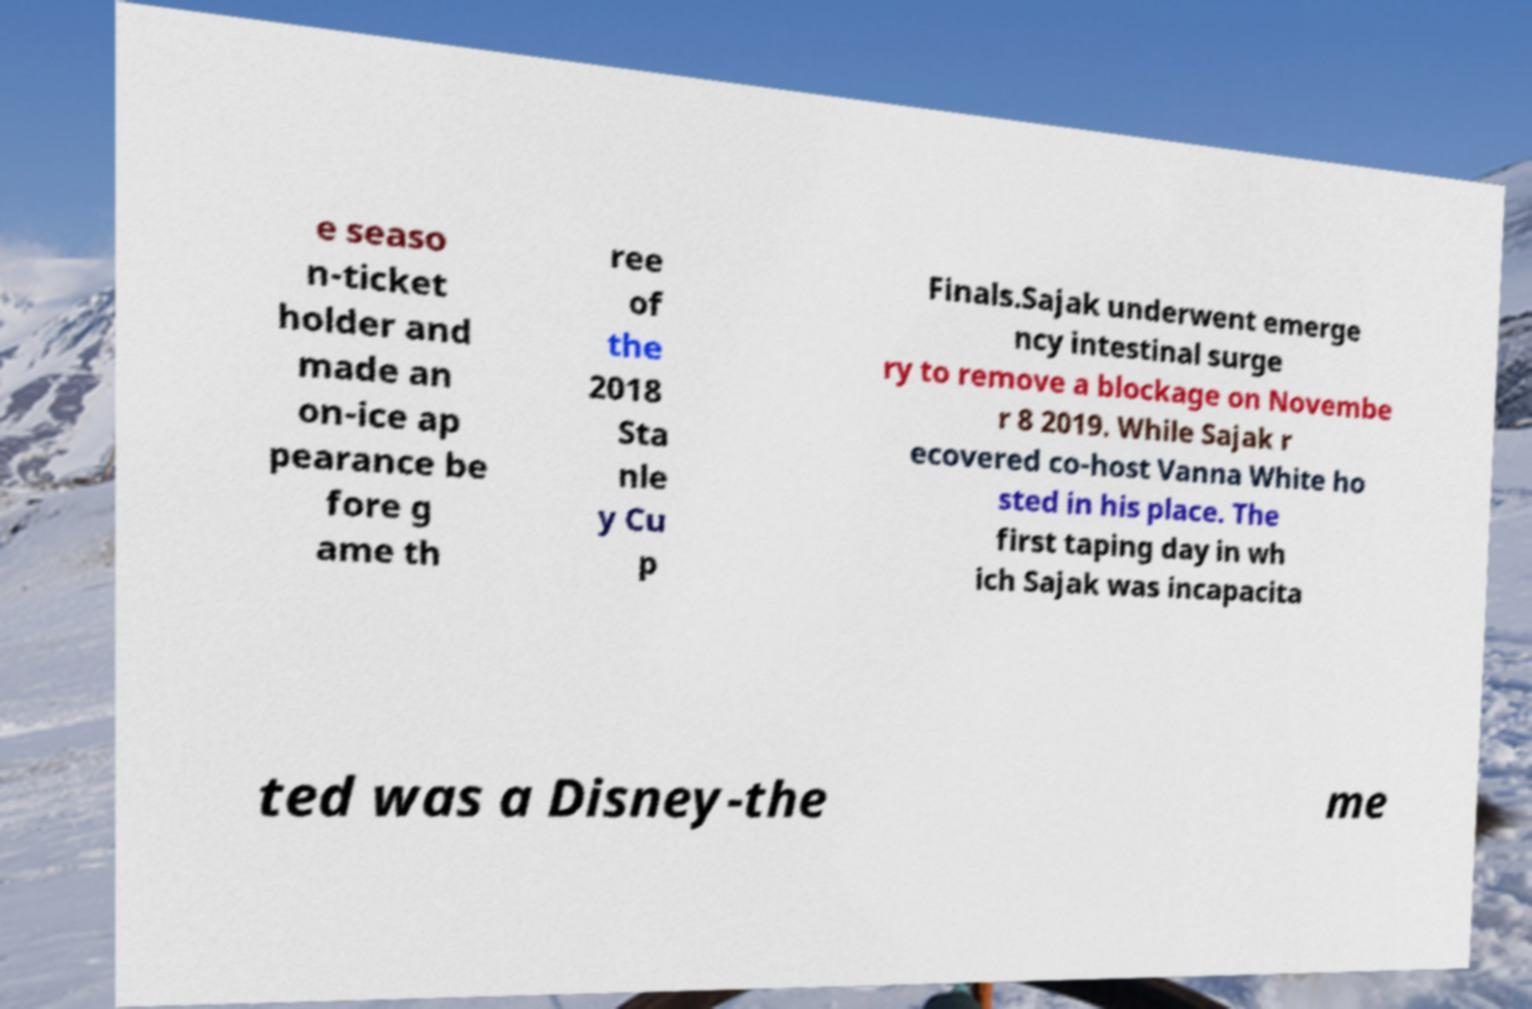Please identify and transcribe the text found in this image. e seaso n-ticket holder and made an on-ice ap pearance be fore g ame th ree of the 2018 Sta nle y Cu p Finals.Sajak underwent emerge ncy intestinal surge ry to remove a blockage on Novembe r 8 2019. While Sajak r ecovered co-host Vanna White ho sted in his place. The first taping day in wh ich Sajak was incapacita ted was a Disney-the me 